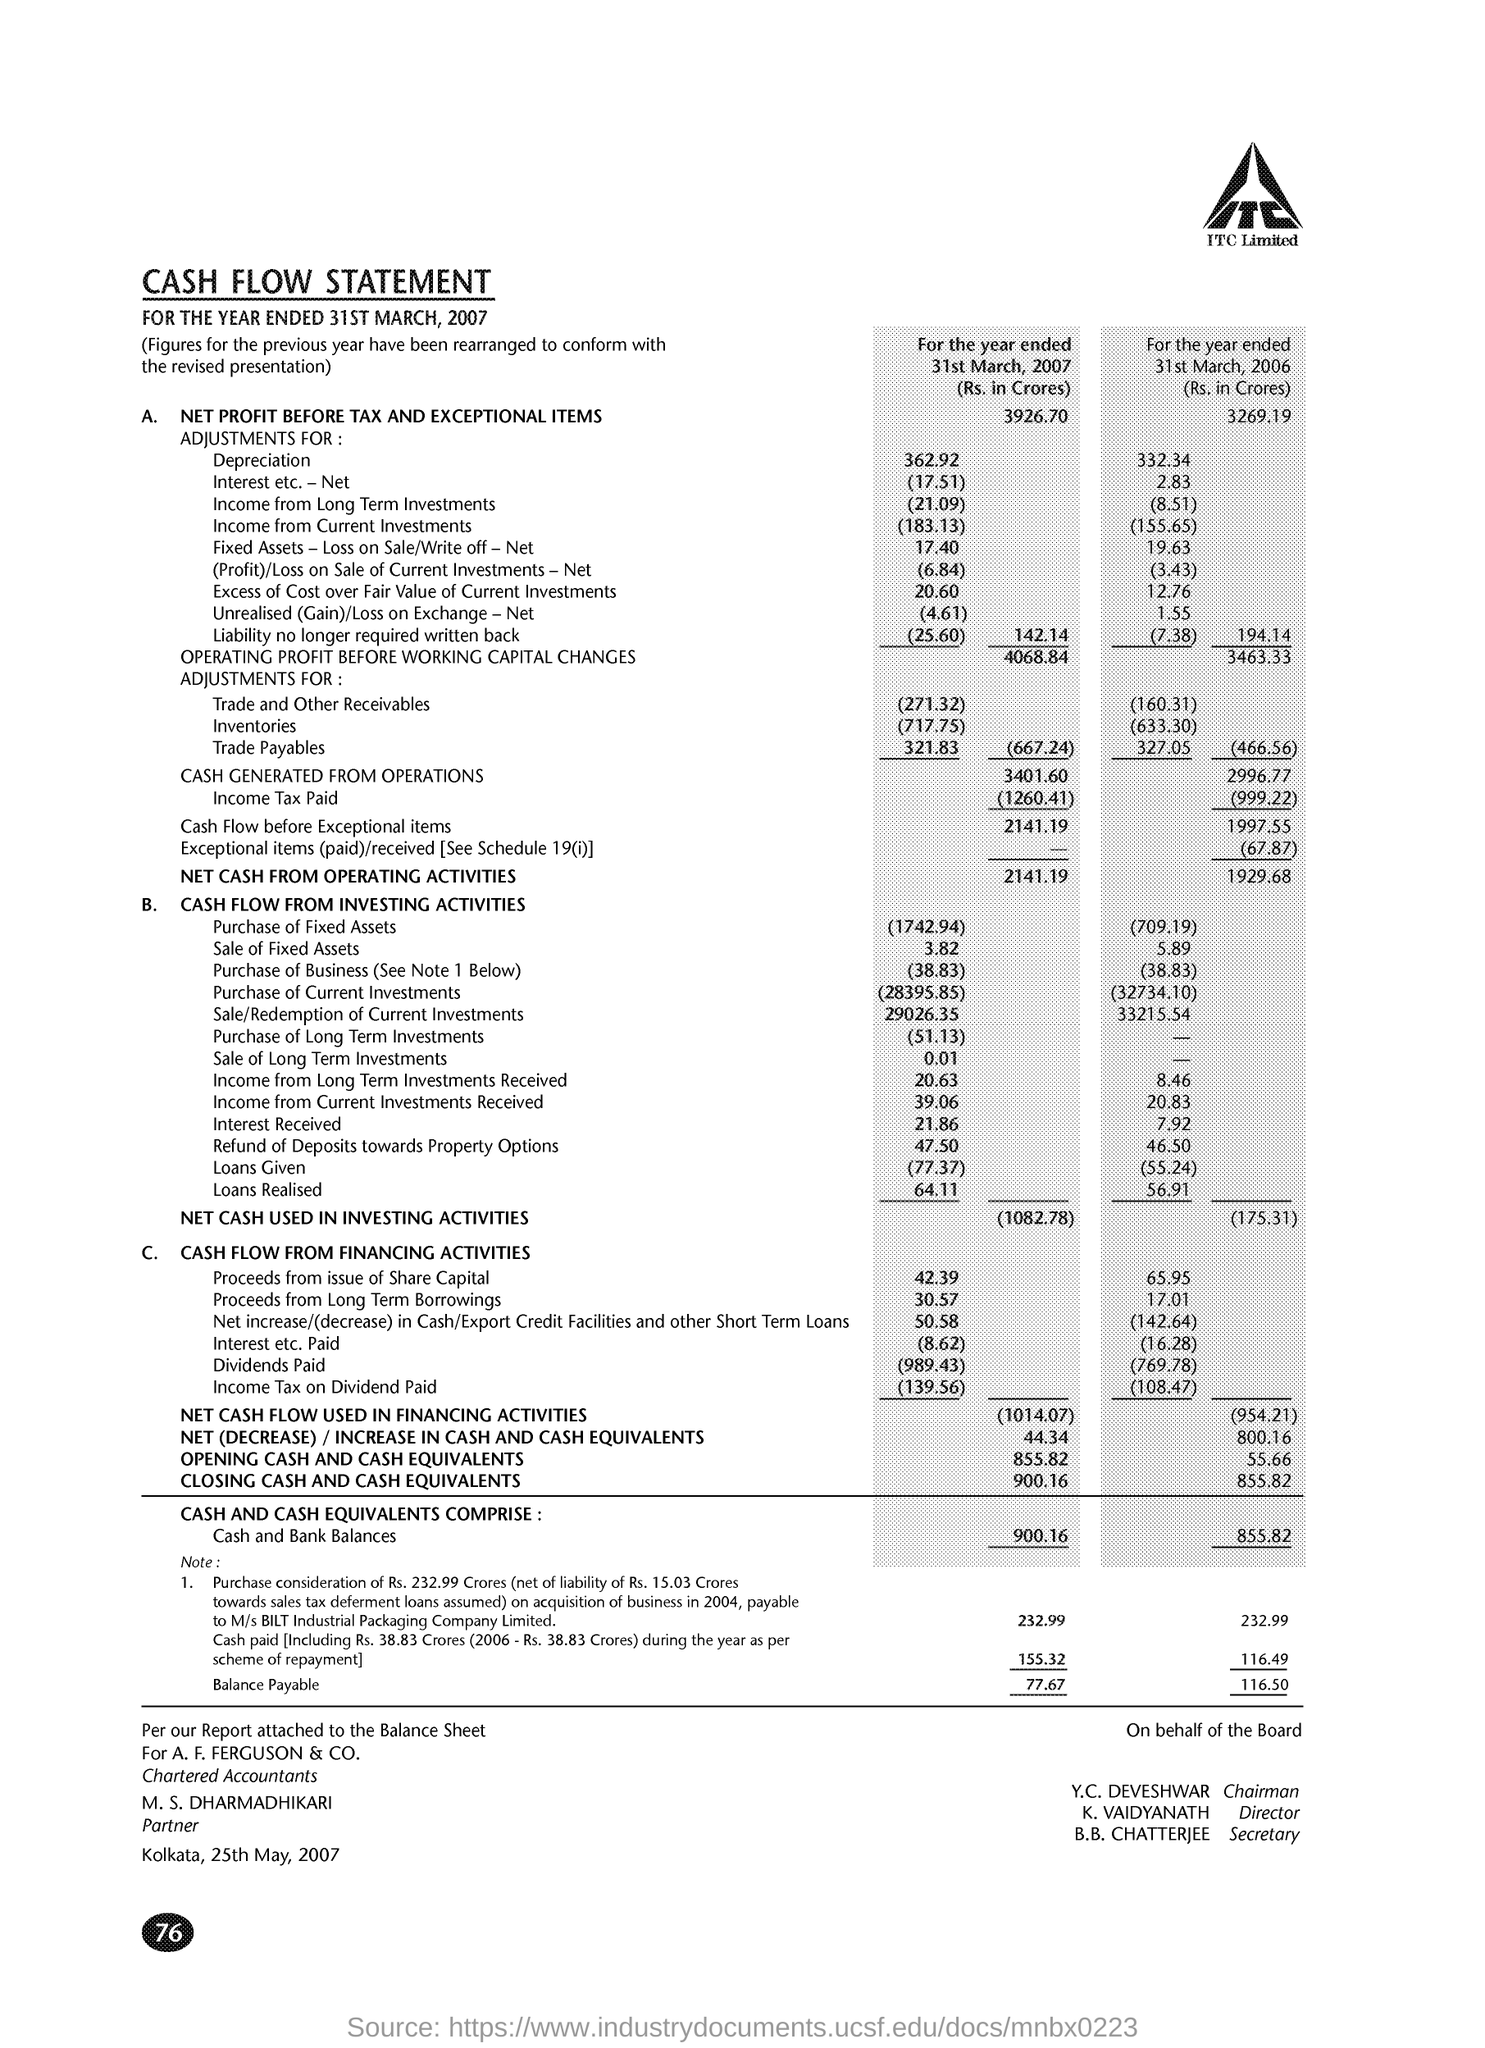What is the Net Profit before tax and exceptional items for the year ended 31st March, 2007(Rs. in Crores) ?
Make the answer very short. 3926.70. How much is the Cash generated from operations for the year ended 31st March, 2007 (Rs. in Crores) ?
Ensure brevity in your answer.  3401.60. What is the Income Tax Paid for the year ended 31st March, 2006 (Rs. in Crores) ?
Give a very brief answer. 999.22. What is the Net Cash from operating activities for the year ended 31st March, 2007( Rs. in Crores) ?
Make the answer very short. 2141.19. What is the Net (Decrease)/ Increase in Cash and Cash Equivalents for the year ended 31st March, 2006 (Rs. in Crores) ?
Provide a short and direct response. 800.16. How much is the Opening Cash & Cash Equivalents for the year ended 31st March, 2007 (Rs. in Crores) ?
Provide a short and direct response. 855.82. 